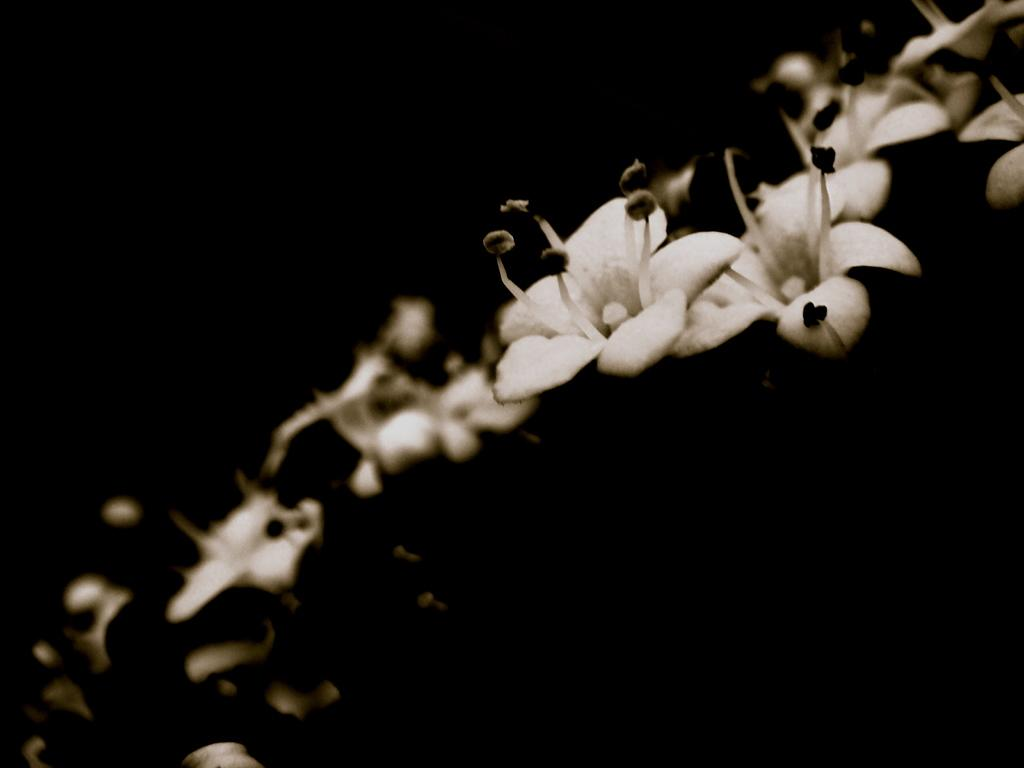What is located in the foreground of the image? There are flowers in the foreground of the image. What color is the background of the image? The background of the image is black. How many sheep can be seen in the front of the image? There are no sheep present in the image. What type of town is visible in the background of the image? There is no town visible in the background of the image, as the background is black. 